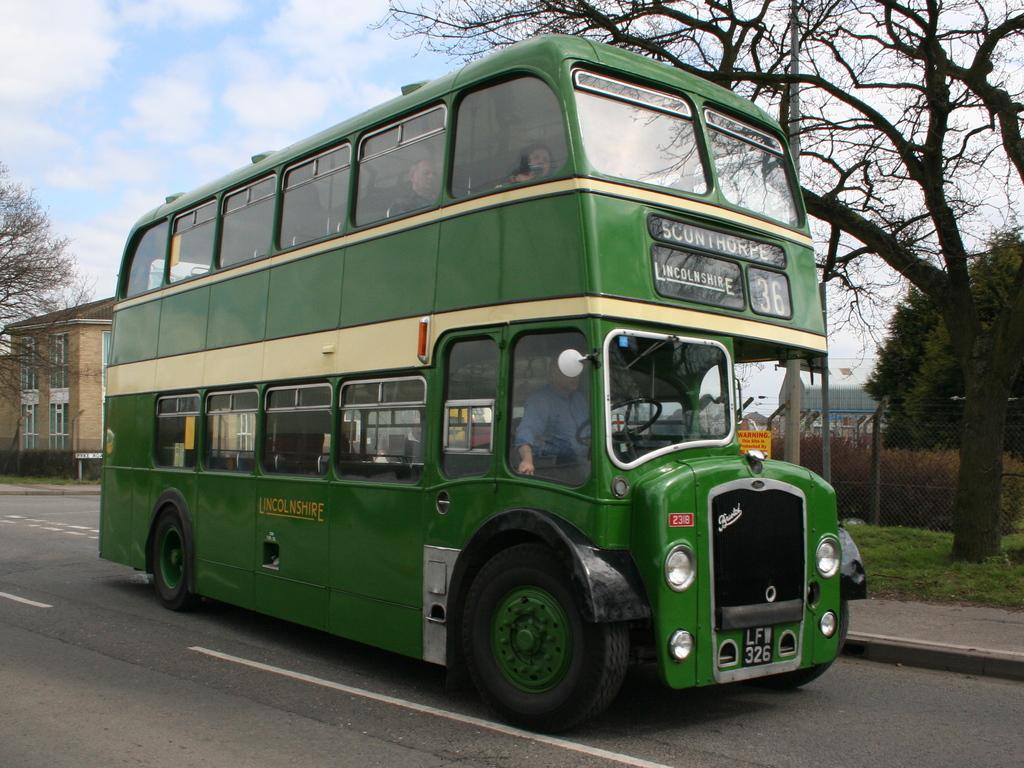<image>
Give a short and clear explanation of the subsequent image. a green double decker bus number 36 for Lincolnshire 